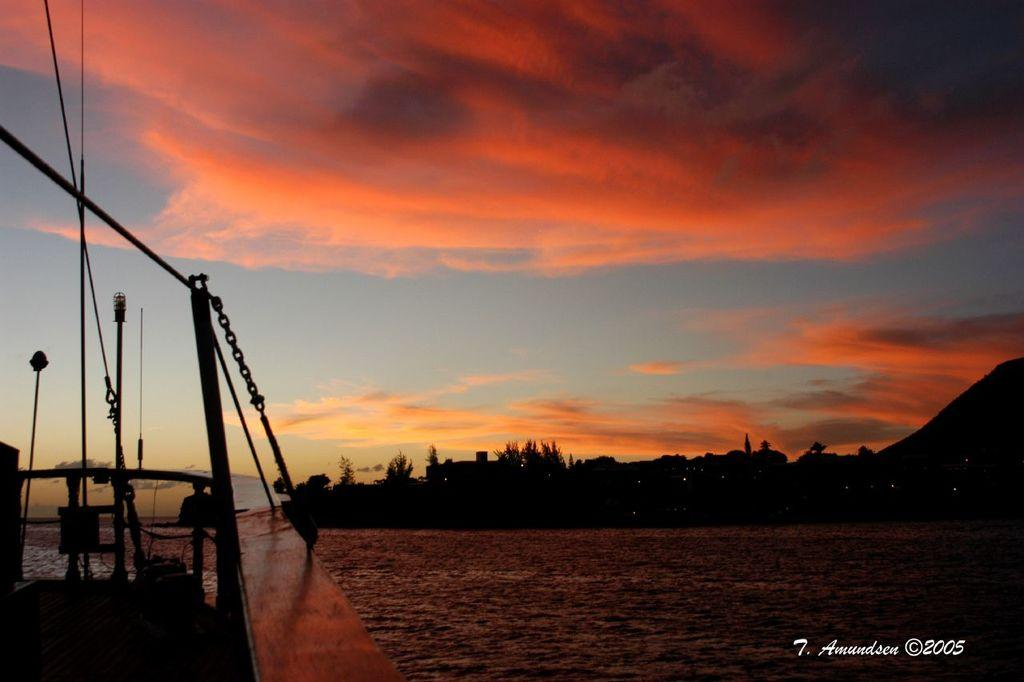What is located on the left side of the image? There is a boat in the water on the left side of the image. What can be seen on the right side of the image? There is a watermark on the right side of the image. What is visible in the background of the image? There are trees in the background of the image. How would you describe the sky in the image? The sky is cloudy in the image. What type of animal can be seen walking through the gate in the image? There is no animal or gate present in the image. What is the head of the person doing in the image? There is no person or head present in the image. 